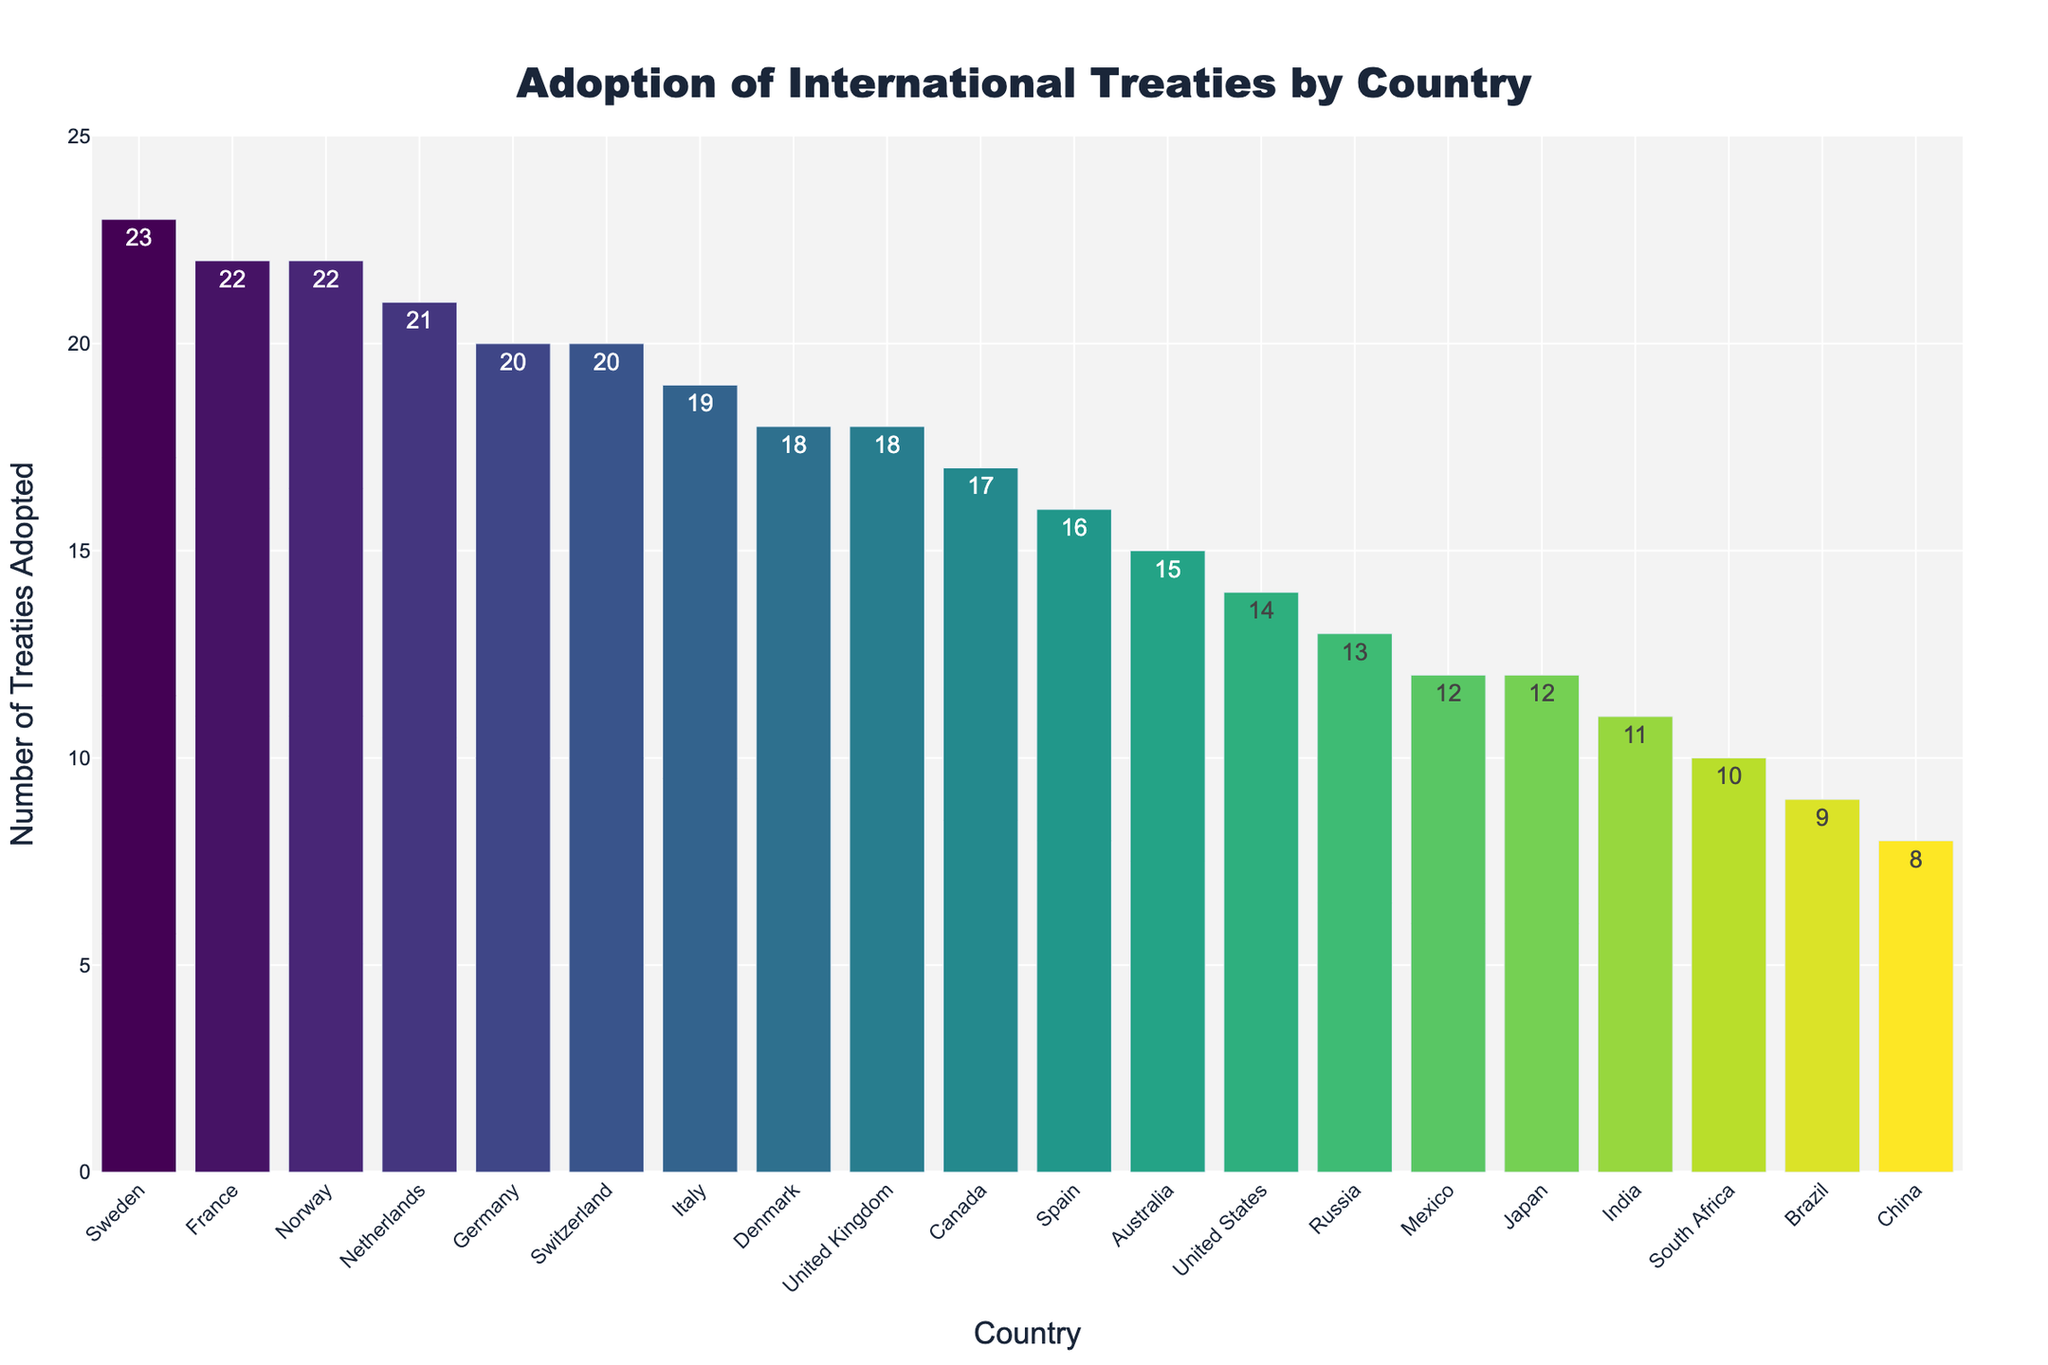What's the country that adopted the highest number of treaties? Look at the bar representing each country and identify the bar with the greatest height. The highest bar belongs to Sweden.
Answer: Sweden Which two countries adopted a combined total of 44 treaties? Identify the countries with the corresponding number of treaties, then sum the values. Adding France (22) and Norway (22) equates to 44.
Answer: France and Norway Is the number of treaties adopted by Japan greater than the number adopted by India? Compare the heights of the bars for Japan and India. Japan adopted 12 treaties, while India adopted 11.
Answer: Yes By how much does the number of treaties adopted by Switzerland exceed that adopted by South Africa? Find the difference in the height of the bars representing Switzerland and South Africa. Switzerland adopted 20 treaties, and South Africa adopted 10, giving a difference of 10.
Answer: 10 Which country has adopted fewer treaties: Brazil or China? Compare the bars representing Brazil and China. Brazil adopted 9 treaties, while China adopted 8.
Answer: China What is the median number of treaties adopted by these countries? List all the numbers of adopted treaties in ascending order: 8, 9, 10, 11, 12, 12, 13, 14, 15, 16, 17, 18, 18, 19, 20, 20, 21, 22, 22, 23. The middle value(s) fall between the 10th and 11th numbers: (16+17)/2 = 16.5
Answer: 16.5 How many more treaties has Germany adopted compared to the United States? Subtract the number of treaties adopted by the United States from those adopted by Germany. Germany: 20, United States: 14. Difference = 20 - 14.
Answer: 6 Which country has the second highest number of treaties adopted? Identify the country with the second highest bar, which is slightly shorter than the highest. Norway and France are tied with 22 treaties each.
Answer: Norway or France Are there more countries that adopted fewer than 15 treaties or more than 15 treaties? Count the countries in each category. Fewer than 15: 6 countries (China, Brazil, South Africa, India, Mexico, Japan). More than 15: 12 countries (USA, UK, France, Germany, Canada, Australia, Italy, Netherlands, Sweden, Switzerland, Spain, Denmark).
Answer: More than 15 What is the average number of treaties adopted by Germany, Italy, and Switzerland? Sum the number of treaties for these countries and divide by the number of countries. (20 + 19 + 20) / 3 = 59 / 3 = 19.67
Answer: 19.67 